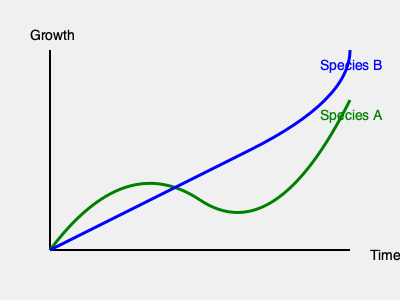Based on the growth patterns shown in the graph, which native plant species would be more suitable for rapid establishment in golf course landscaping, considering both environmental impact and playability? To determine the most suitable native plant species for rapid establishment in golf course landscaping, we need to analyze the growth patterns shown in the graph:

1. Identify the species:
   - Green curve represents Species A
   - Blue curve represents Species B

2. Analyze growth rates:
   - Species A shows a slower initial growth rate but steadier long-term growth
   - Species B demonstrates faster initial growth but slows down over time

3. Consider environmental impact:
   - Rapid establishment helps prevent soil erosion and promotes biodiversity
   - Species B's faster initial growth would provide quicker ground cover

4. Evaluate playability:
   - Golf courses require consistent playing surfaces
   - Species A's steadier growth may lead to more uniform coverage over time

5. Balance short-term and long-term benefits:
   - Species B offers quicker establishment, which is crucial for new or renovated areas
   - Species A might provide better long-term stability

6. Consider maintenance:
   - Species B may require more frequent trimming due to rapid initial growth
   - Species A could potentially need less maintenance over time

Given the importance of rapid establishment for environmental conservation and initial playability, Species B would be more suitable. Its faster initial growth provides quicker ground cover, reducing soil erosion and establishing a playable surface more rapidly. While it may require more maintenance in the short term, the environmental benefits of quick establishment outweigh this consideration.
Answer: Species B 